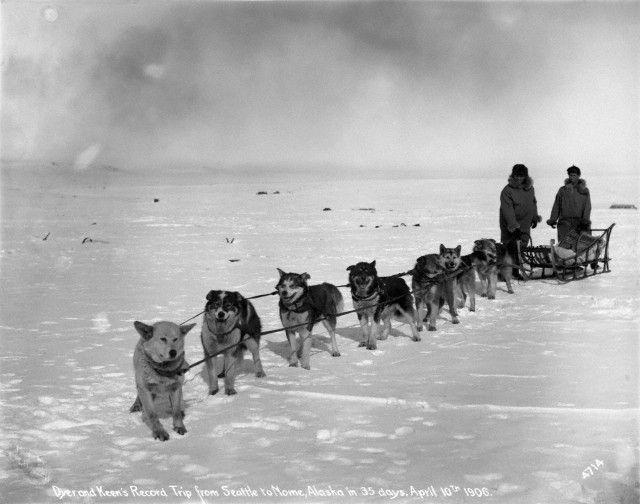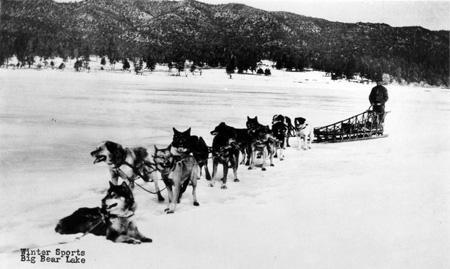The first image is the image on the left, the second image is the image on the right. Evaluate the accuracy of this statement regarding the images: "One of the images shows flat terrain with no trees behind the sled dogs.". Is it true? Answer yes or no. Yes. The first image is the image on the left, the second image is the image on the right. For the images displayed, is the sentence "The lead dog of a sled team aimed leftward is reclining on the snow with both front paws extended and is gazing to the side." factually correct? Answer yes or no. Yes. 